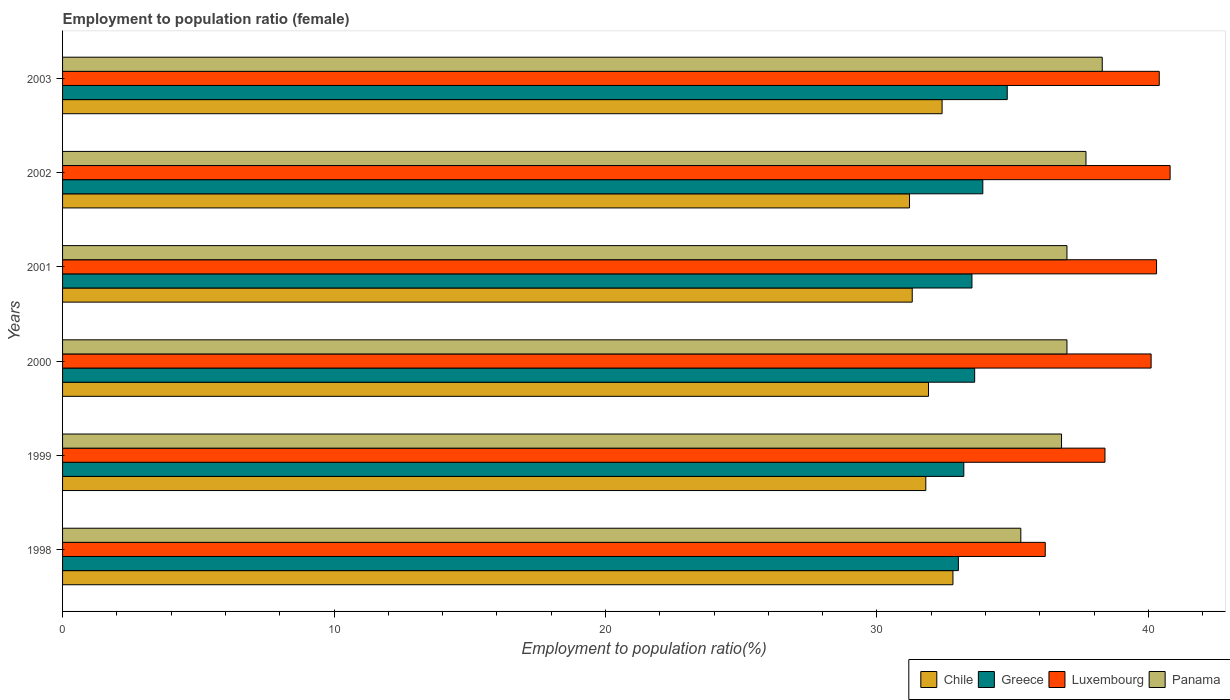How many groups of bars are there?
Provide a short and direct response. 6. Are the number of bars per tick equal to the number of legend labels?
Ensure brevity in your answer.  Yes. How many bars are there on the 2nd tick from the top?
Your answer should be compact. 4. How many bars are there on the 4th tick from the bottom?
Provide a short and direct response. 4. What is the label of the 6th group of bars from the top?
Offer a very short reply. 1998. In how many cases, is the number of bars for a given year not equal to the number of legend labels?
Ensure brevity in your answer.  0. What is the employment to population ratio in Chile in 1998?
Give a very brief answer. 32.8. Across all years, what is the maximum employment to population ratio in Luxembourg?
Your answer should be very brief. 40.8. Across all years, what is the minimum employment to population ratio in Greece?
Keep it short and to the point. 33. In which year was the employment to population ratio in Greece maximum?
Your response must be concise. 2003. In which year was the employment to population ratio in Greece minimum?
Ensure brevity in your answer.  1998. What is the total employment to population ratio in Luxembourg in the graph?
Offer a very short reply. 236.2. What is the difference between the employment to population ratio in Greece in 2000 and that in 2001?
Offer a very short reply. 0.1. What is the difference between the employment to population ratio in Chile in 1998 and the employment to population ratio in Luxembourg in 2002?
Give a very brief answer. -8. What is the average employment to population ratio in Greece per year?
Offer a terse response. 33.67. In the year 2002, what is the difference between the employment to population ratio in Panama and employment to population ratio in Greece?
Ensure brevity in your answer.  3.8. What is the ratio of the employment to population ratio in Chile in 1998 to that in 2001?
Offer a very short reply. 1.05. Is the employment to population ratio in Greece in 1999 less than that in 2002?
Your response must be concise. Yes. What is the difference between the highest and the second highest employment to population ratio in Greece?
Your response must be concise. 0.9. What is the difference between the highest and the lowest employment to population ratio in Greece?
Ensure brevity in your answer.  1.8. In how many years, is the employment to population ratio in Chile greater than the average employment to population ratio in Chile taken over all years?
Provide a succinct answer. 2. Is the sum of the employment to population ratio in Panama in 1999 and 2000 greater than the maximum employment to population ratio in Luxembourg across all years?
Offer a terse response. Yes. Is it the case that in every year, the sum of the employment to population ratio in Greece and employment to population ratio in Chile is greater than the sum of employment to population ratio in Panama and employment to population ratio in Luxembourg?
Give a very brief answer. No. What does the 2nd bar from the top in 2003 represents?
Your answer should be compact. Luxembourg. What does the 3rd bar from the bottom in 2000 represents?
Your answer should be compact. Luxembourg. What is the difference between two consecutive major ticks on the X-axis?
Your answer should be very brief. 10. Does the graph contain any zero values?
Your answer should be compact. No. Where does the legend appear in the graph?
Provide a succinct answer. Bottom right. What is the title of the graph?
Keep it short and to the point. Employment to population ratio (female). What is the Employment to population ratio(%) of Chile in 1998?
Your response must be concise. 32.8. What is the Employment to population ratio(%) of Luxembourg in 1998?
Offer a very short reply. 36.2. What is the Employment to population ratio(%) in Panama in 1998?
Offer a very short reply. 35.3. What is the Employment to population ratio(%) of Chile in 1999?
Ensure brevity in your answer.  31.8. What is the Employment to population ratio(%) of Greece in 1999?
Offer a very short reply. 33.2. What is the Employment to population ratio(%) of Luxembourg in 1999?
Give a very brief answer. 38.4. What is the Employment to population ratio(%) of Panama in 1999?
Your response must be concise. 36.8. What is the Employment to population ratio(%) of Chile in 2000?
Offer a very short reply. 31.9. What is the Employment to population ratio(%) in Greece in 2000?
Your response must be concise. 33.6. What is the Employment to population ratio(%) of Luxembourg in 2000?
Your response must be concise. 40.1. What is the Employment to population ratio(%) of Panama in 2000?
Provide a short and direct response. 37. What is the Employment to population ratio(%) of Chile in 2001?
Provide a short and direct response. 31.3. What is the Employment to population ratio(%) of Greece in 2001?
Ensure brevity in your answer.  33.5. What is the Employment to population ratio(%) in Luxembourg in 2001?
Make the answer very short. 40.3. What is the Employment to population ratio(%) in Panama in 2001?
Provide a short and direct response. 37. What is the Employment to population ratio(%) of Chile in 2002?
Your answer should be compact. 31.2. What is the Employment to population ratio(%) in Greece in 2002?
Keep it short and to the point. 33.9. What is the Employment to population ratio(%) in Luxembourg in 2002?
Provide a succinct answer. 40.8. What is the Employment to population ratio(%) of Panama in 2002?
Provide a short and direct response. 37.7. What is the Employment to population ratio(%) of Chile in 2003?
Offer a very short reply. 32.4. What is the Employment to population ratio(%) in Greece in 2003?
Offer a terse response. 34.8. What is the Employment to population ratio(%) in Luxembourg in 2003?
Give a very brief answer. 40.4. What is the Employment to population ratio(%) in Panama in 2003?
Your answer should be very brief. 38.3. Across all years, what is the maximum Employment to population ratio(%) in Chile?
Keep it short and to the point. 32.8. Across all years, what is the maximum Employment to population ratio(%) in Greece?
Offer a very short reply. 34.8. Across all years, what is the maximum Employment to population ratio(%) of Luxembourg?
Offer a terse response. 40.8. Across all years, what is the maximum Employment to population ratio(%) of Panama?
Provide a succinct answer. 38.3. Across all years, what is the minimum Employment to population ratio(%) of Chile?
Offer a very short reply. 31.2. Across all years, what is the minimum Employment to population ratio(%) in Greece?
Your answer should be very brief. 33. Across all years, what is the minimum Employment to population ratio(%) of Luxembourg?
Offer a terse response. 36.2. Across all years, what is the minimum Employment to population ratio(%) of Panama?
Keep it short and to the point. 35.3. What is the total Employment to population ratio(%) of Chile in the graph?
Offer a very short reply. 191.4. What is the total Employment to population ratio(%) of Greece in the graph?
Make the answer very short. 202. What is the total Employment to population ratio(%) of Luxembourg in the graph?
Ensure brevity in your answer.  236.2. What is the total Employment to population ratio(%) in Panama in the graph?
Offer a very short reply. 222.1. What is the difference between the Employment to population ratio(%) of Panama in 1998 and that in 1999?
Your answer should be compact. -1.5. What is the difference between the Employment to population ratio(%) of Greece in 1998 and that in 2000?
Ensure brevity in your answer.  -0.6. What is the difference between the Employment to population ratio(%) in Luxembourg in 1998 and that in 2000?
Your response must be concise. -3.9. What is the difference between the Employment to population ratio(%) of Luxembourg in 1998 and that in 2001?
Offer a very short reply. -4.1. What is the difference between the Employment to population ratio(%) in Chile in 1998 and that in 2002?
Your answer should be very brief. 1.6. What is the difference between the Employment to population ratio(%) of Greece in 1998 and that in 2002?
Provide a short and direct response. -0.9. What is the difference between the Employment to population ratio(%) in Luxembourg in 1998 and that in 2002?
Make the answer very short. -4.6. What is the difference between the Employment to population ratio(%) in Chile in 1998 and that in 2003?
Your response must be concise. 0.4. What is the difference between the Employment to population ratio(%) of Greece in 1998 and that in 2003?
Keep it short and to the point. -1.8. What is the difference between the Employment to population ratio(%) in Luxembourg in 1998 and that in 2003?
Ensure brevity in your answer.  -4.2. What is the difference between the Employment to population ratio(%) in Chile in 1999 and that in 2000?
Your response must be concise. -0.1. What is the difference between the Employment to population ratio(%) of Luxembourg in 1999 and that in 2000?
Give a very brief answer. -1.7. What is the difference between the Employment to population ratio(%) in Panama in 1999 and that in 2000?
Keep it short and to the point. -0.2. What is the difference between the Employment to population ratio(%) of Chile in 1999 and that in 2001?
Provide a succinct answer. 0.5. What is the difference between the Employment to population ratio(%) in Greece in 1999 and that in 2001?
Keep it short and to the point. -0.3. What is the difference between the Employment to population ratio(%) of Chile in 1999 and that in 2002?
Offer a terse response. 0.6. What is the difference between the Employment to population ratio(%) of Chile in 1999 and that in 2003?
Offer a very short reply. -0.6. What is the difference between the Employment to population ratio(%) in Luxembourg in 1999 and that in 2003?
Keep it short and to the point. -2. What is the difference between the Employment to population ratio(%) in Greece in 2000 and that in 2001?
Your response must be concise. 0.1. What is the difference between the Employment to population ratio(%) in Greece in 2000 and that in 2002?
Ensure brevity in your answer.  -0.3. What is the difference between the Employment to population ratio(%) in Luxembourg in 2000 and that in 2002?
Offer a terse response. -0.7. What is the difference between the Employment to population ratio(%) of Chile in 2000 and that in 2003?
Your answer should be compact. -0.5. What is the difference between the Employment to population ratio(%) of Greece in 2000 and that in 2003?
Your response must be concise. -1.2. What is the difference between the Employment to population ratio(%) in Luxembourg in 2000 and that in 2003?
Keep it short and to the point. -0.3. What is the difference between the Employment to population ratio(%) in Greece in 2001 and that in 2002?
Provide a succinct answer. -0.4. What is the difference between the Employment to population ratio(%) in Greece in 2001 and that in 2003?
Make the answer very short. -1.3. What is the difference between the Employment to population ratio(%) in Luxembourg in 2001 and that in 2003?
Make the answer very short. -0.1. What is the difference between the Employment to population ratio(%) in Chile in 2002 and that in 2003?
Your answer should be very brief. -1.2. What is the difference between the Employment to population ratio(%) of Chile in 1998 and the Employment to population ratio(%) of Greece in 1999?
Provide a short and direct response. -0.4. What is the difference between the Employment to population ratio(%) of Greece in 1998 and the Employment to population ratio(%) of Panama in 1999?
Ensure brevity in your answer.  -3.8. What is the difference between the Employment to population ratio(%) of Luxembourg in 1998 and the Employment to population ratio(%) of Panama in 1999?
Your answer should be compact. -0.6. What is the difference between the Employment to population ratio(%) in Chile in 1998 and the Employment to population ratio(%) in Greece in 2000?
Keep it short and to the point. -0.8. What is the difference between the Employment to population ratio(%) in Chile in 1998 and the Employment to population ratio(%) in Luxembourg in 2000?
Give a very brief answer. -7.3. What is the difference between the Employment to population ratio(%) of Greece in 1998 and the Employment to population ratio(%) of Panama in 2000?
Keep it short and to the point. -4. What is the difference between the Employment to population ratio(%) of Chile in 1998 and the Employment to population ratio(%) of Greece in 2001?
Your answer should be compact. -0.7. What is the difference between the Employment to population ratio(%) of Greece in 1998 and the Employment to population ratio(%) of Luxembourg in 2001?
Offer a very short reply. -7.3. What is the difference between the Employment to population ratio(%) in Chile in 1998 and the Employment to population ratio(%) in Greece in 2002?
Offer a terse response. -1.1. What is the difference between the Employment to population ratio(%) of Chile in 1998 and the Employment to population ratio(%) of Panama in 2002?
Offer a very short reply. -4.9. What is the difference between the Employment to population ratio(%) in Luxembourg in 1998 and the Employment to population ratio(%) in Panama in 2002?
Provide a short and direct response. -1.5. What is the difference between the Employment to population ratio(%) in Greece in 1998 and the Employment to population ratio(%) in Panama in 2003?
Give a very brief answer. -5.3. What is the difference between the Employment to population ratio(%) of Luxembourg in 1998 and the Employment to population ratio(%) of Panama in 2003?
Ensure brevity in your answer.  -2.1. What is the difference between the Employment to population ratio(%) in Chile in 1999 and the Employment to population ratio(%) in Panama in 2000?
Offer a terse response. -5.2. What is the difference between the Employment to population ratio(%) in Chile in 1999 and the Employment to population ratio(%) in Greece in 2001?
Offer a terse response. -1.7. What is the difference between the Employment to population ratio(%) in Chile in 1999 and the Employment to population ratio(%) in Luxembourg in 2001?
Make the answer very short. -8.5. What is the difference between the Employment to population ratio(%) in Greece in 1999 and the Employment to population ratio(%) in Luxembourg in 2001?
Ensure brevity in your answer.  -7.1. What is the difference between the Employment to population ratio(%) in Greece in 1999 and the Employment to population ratio(%) in Panama in 2001?
Ensure brevity in your answer.  -3.8. What is the difference between the Employment to population ratio(%) of Chile in 1999 and the Employment to population ratio(%) of Luxembourg in 2002?
Offer a very short reply. -9. What is the difference between the Employment to population ratio(%) in Greece in 1999 and the Employment to population ratio(%) in Luxembourg in 2002?
Provide a short and direct response. -7.6. What is the difference between the Employment to population ratio(%) of Greece in 1999 and the Employment to population ratio(%) of Panama in 2002?
Offer a terse response. -4.5. What is the difference between the Employment to population ratio(%) in Luxembourg in 1999 and the Employment to population ratio(%) in Panama in 2002?
Offer a terse response. 0.7. What is the difference between the Employment to population ratio(%) of Chile in 1999 and the Employment to population ratio(%) of Greece in 2003?
Offer a terse response. -3. What is the difference between the Employment to population ratio(%) in Chile in 1999 and the Employment to population ratio(%) in Panama in 2003?
Provide a succinct answer. -6.5. What is the difference between the Employment to population ratio(%) of Greece in 1999 and the Employment to population ratio(%) of Panama in 2003?
Offer a terse response. -5.1. What is the difference between the Employment to population ratio(%) in Luxembourg in 1999 and the Employment to population ratio(%) in Panama in 2003?
Your answer should be compact. 0.1. What is the difference between the Employment to population ratio(%) in Greece in 2000 and the Employment to population ratio(%) in Panama in 2001?
Provide a short and direct response. -3.4. What is the difference between the Employment to population ratio(%) of Chile in 2000 and the Employment to population ratio(%) of Greece in 2002?
Keep it short and to the point. -2. What is the difference between the Employment to population ratio(%) in Chile in 2000 and the Employment to population ratio(%) in Luxembourg in 2002?
Keep it short and to the point. -8.9. What is the difference between the Employment to population ratio(%) of Chile in 2000 and the Employment to population ratio(%) of Panama in 2002?
Your answer should be compact. -5.8. What is the difference between the Employment to population ratio(%) of Greece in 2000 and the Employment to population ratio(%) of Luxembourg in 2002?
Ensure brevity in your answer.  -7.2. What is the difference between the Employment to population ratio(%) of Luxembourg in 2000 and the Employment to population ratio(%) of Panama in 2002?
Your answer should be very brief. 2.4. What is the difference between the Employment to population ratio(%) of Chile in 2000 and the Employment to population ratio(%) of Greece in 2003?
Your answer should be very brief. -2.9. What is the difference between the Employment to population ratio(%) of Chile in 2000 and the Employment to population ratio(%) of Luxembourg in 2003?
Give a very brief answer. -8.5. What is the difference between the Employment to population ratio(%) of Chile in 2001 and the Employment to population ratio(%) of Luxembourg in 2002?
Ensure brevity in your answer.  -9.5. What is the difference between the Employment to population ratio(%) of Chile in 2001 and the Employment to population ratio(%) of Panama in 2002?
Provide a succinct answer. -6.4. What is the difference between the Employment to population ratio(%) of Greece in 2001 and the Employment to population ratio(%) of Luxembourg in 2002?
Ensure brevity in your answer.  -7.3. What is the difference between the Employment to population ratio(%) in Greece in 2001 and the Employment to population ratio(%) in Panama in 2002?
Make the answer very short. -4.2. What is the difference between the Employment to population ratio(%) in Luxembourg in 2001 and the Employment to population ratio(%) in Panama in 2002?
Ensure brevity in your answer.  2.6. What is the difference between the Employment to population ratio(%) in Greece in 2001 and the Employment to population ratio(%) in Luxembourg in 2003?
Provide a succinct answer. -6.9. What is the difference between the Employment to population ratio(%) of Greece in 2001 and the Employment to population ratio(%) of Panama in 2003?
Ensure brevity in your answer.  -4.8. What is the difference between the Employment to population ratio(%) in Chile in 2002 and the Employment to population ratio(%) in Greece in 2003?
Offer a very short reply. -3.6. What is the difference between the Employment to population ratio(%) in Chile in 2002 and the Employment to population ratio(%) in Luxembourg in 2003?
Your response must be concise. -9.2. What is the difference between the Employment to population ratio(%) of Greece in 2002 and the Employment to population ratio(%) of Luxembourg in 2003?
Your answer should be compact. -6.5. What is the average Employment to population ratio(%) of Chile per year?
Provide a succinct answer. 31.9. What is the average Employment to population ratio(%) of Greece per year?
Ensure brevity in your answer.  33.67. What is the average Employment to population ratio(%) in Luxembourg per year?
Offer a very short reply. 39.37. What is the average Employment to population ratio(%) in Panama per year?
Make the answer very short. 37.02. In the year 1998, what is the difference between the Employment to population ratio(%) in Chile and Employment to population ratio(%) in Luxembourg?
Ensure brevity in your answer.  -3.4. In the year 1998, what is the difference between the Employment to population ratio(%) in Chile and Employment to population ratio(%) in Panama?
Provide a short and direct response. -2.5. In the year 1998, what is the difference between the Employment to population ratio(%) of Greece and Employment to population ratio(%) of Luxembourg?
Keep it short and to the point. -3.2. In the year 1998, what is the difference between the Employment to population ratio(%) in Luxembourg and Employment to population ratio(%) in Panama?
Make the answer very short. 0.9. In the year 1999, what is the difference between the Employment to population ratio(%) of Chile and Employment to population ratio(%) of Luxembourg?
Your answer should be compact. -6.6. In the year 1999, what is the difference between the Employment to population ratio(%) of Chile and Employment to population ratio(%) of Panama?
Give a very brief answer. -5. In the year 1999, what is the difference between the Employment to population ratio(%) of Greece and Employment to population ratio(%) of Luxembourg?
Your answer should be very brief. -5.2. In the year 1999, what is the difference between the Employment to population ratio(%) of Greece and Employment to population ratio(%) of Panama?
Make the answer very short. -3.6. In the year 2000, what is the difference between the Employment to population ratio(%) in Chile and Employment to population ratio(%) in Panama?
Your answer should be very brief. -5.1. In the year 2001, what is the difference between the Employment to population ratio(%) in Chile and Employment to population ratio(%) in Greece?
Make the answer very short. -2.2. In the year 2001, what is the difference between the Employment to population ratio(%) in Chile and Employment to population ratio(%) in Luxembourg?
Make the answer very short. -9. In the year 2001, what is the difference between the Employment to population ratio(%) of Greece and Employment to population ratio(%) of Panama?
Provide a short and direct response. -3.5. In the year 2001, what is the difference between the Employment to population ratio(%) in Luxembourg and Employment to population ratio(%) in Panama?
Make the answer very short. 3.3. In the year 2002, what is the difference between the Employment to population ratio(%) in Chile and Employment to population ratio(%) in Luxembourg?
Your response must be concise. -9.6. In the year 2002, what is the difference between the Employment to population ratio(%) in Greece and Employment to population ratio(%) in Luxembourg?
Offer a very short reply. -6.9. In the year 2003, what is the difference between the Employment to population ratio(%) of Chile and Employment to population ratio(%) of Greece?
Make the answer very short. -2.4. In the year 2003, what is the difference between the Employment to population ratio(%) in Chile and Employment to population ratio(%) in Luxembourg?
Provide a short and direct response. -8. In the year 2003, what is the difference between the Employment to population ratio(%) in Greece and Employment to population ratio(%) in Panama?
Offer a very short reply. -3.5. In the year 2003, what is the difference between the Employment to population ratio(%) in Luxembourg and Employment to population ratio(%) in Panama?
Your answer should be very brief. 2.1. What is the ratio of the Employment to population ratio(%) in Chile in 1998 to that in 1999?
Your answer should be very brief. 1.03. What is the ratio of the Employment to population ratio(%) of Luxembourg in 1998 to that in 1999?
Keep it short and to the point. 0.94. What is the ratio of the Employment to population ratio(%) in Panama in 1998 to that in 1999?
Your answer should be very brief. 0.96. What is the ratio of the Employment to population ratio(%) in Chile in 1998 to that in 2000?
Provide a succinct answer. 1.03. What is the ratio of the Employment to population ratio(%) in Greece in 1998 to that in 2000?
Offer a very short reply. 0.98. What is the ratio of the Employment to population ratio(%) of Luxembourg in 1998 to that in 2000?
Keep it short and to the point. 0.9. What is the ratio of the Employment to population ratio(%) in Panama in 1998 to that in 2000?
Your answer should be very brief. 0.95. What is the ratio of the Employment to population ratio(%) of Chile in 1998 to that in 2001?
Give a very brief answer. 1.05. What is the ratio of the Employment to population ratio(%) in Greece in 1998 to that in 2001?
Offer a terse response. 0.99. What is the ratio of the Employment to population ratio(%) in Luxembourg in 1998 to that in 2001?
Offer a terse response. 0.9. What is the ratio of the Employment to population ratio(%) in Panama in 1998 to that in 2001?
Offer a very short reply. 0.95. What is the ratio of the Employment to population ratio(%) in Chile in 1998 to that in 2002?
Your answer should be very brief. 1.05. What is the ratio of the Employment to population ratio(%) of Greece in 1998 to that in 2002?
Keep it short and to the point. 0.97. What is the ratio of the Employment to population ratio(%) in Luxembourg in 1998 to that in 2002?
Make the answer very short. 0.89. What is the ratio of the Employment to population ratio(%) in Panama in 1998 to that in 2002?
Offer a terse response. 0.94. What is the ratio of the Employment to population ratio(%) of Chile in 1998 to that in 2003?
Offer a terse response. 1.01. What is the ratio of the Employment to population ratio(%) in Greece in 1998 to that in 2003?
Keep it short and to the point. 0.95. What is the ratio of the Employment to population ratio(%) in Luxembourg in 1998 to that in 2003?
Offer a terse response. 0.9. What is the ratio of the Employment to population ratio(%) in Panama in 1998 to that in 2003?
Offer a terse response. 0.92. What is the ratio of the Employment to population ratio(%) of Chile in 1999 to that in 2000?
Keep it short and to the point. 1. What is the ratio of the Employment to population ratio(%) of Greece in 1999 to that in 2000?
Make the answer very short. 0.99. What is the ratio of the Employment to population ratio(%) in Luxembourg in 1999 to that in 2000?
Make the answer very short. 0.96. What is the ratio of the Employment to population ratio(%) in Greece in 1999 to that in 2001?
Ensure brevity in your answer.  0.99. What is the ratio of the Employment to population ratio(%) in Luxembourg in 1999 to that in 2001?
Ensure brevity in your answer.  0.95. What is the ratio of the Employment to population ratio(%) of Panama in 1999 to that in 2001?
Provide a short and direct response. 0.99. What is the ratio of the Employment to population ratio(%) of Chile in 1999 to that in 2002?
Provide a short and direct response. 1.02. What is the ratio of the Employment to population ratio(%) of Greece in 1999 to that in 2002?
Your answer should be compact. 0.98. What is the ratio of the Employment to population ratio(%) of Panama in 1999 to that in 2002?
Provide a succinct answer. 0.98. What is the ratio of the Employment to population ratio(%) in Chile in 1999 to that in 2003?
Your answer should be very brief. 0.98. What is the ratio of the Employment to population ratio(%) in Greece in 1999 to that in 2003?
Offer a terse response. 0.95. What is the ratio of the Employment to population ratio(%) of Luxembourg in 1999 to that in 2003?
Provide a short and direct response. 0.95. What is the ratio of the Employment to population ratio(%) in Panama in 1999 to that in 2003?
Give a very brief answer. 0.96. What is the ratio of the Employment to population ratio(%) of Chile in 2000 to that in 2001?
Provide a succinct answer. 1.02. What is the ratio of the Employment to population ratio(%) in Greece in 2000 to that in 2001?
Offer a very short reply. 1. What is the ratio of the Employment to population ratio(%) in Luxembourg in 2000 to that in 2001?
Ensure brevity in your answer.  0.99. What is the ratio of the Employment to population ratio(%) of Panama in 2000 to that in 2001?
Provide a succinct answer. 1. What is the ratio of the Employment to population ratio(%) in Chile in 2000 to that in 2002?
Keep it short and to the point. 1.02. What is the ratio of the Employment to population ratio(%) of Luxembourg in 2000 to that in 2002?
Give a very brief answer. 0.98. What is the ratio of the Employment to population ratio(%) in Panama in 2000 to that in 2002?
Offer a very short reply. 0.98. What is the ratio of the Employment to population ratio(%) of Chile in 2000 to that in 2003?
Provide a succinct answer. 0.98. What is the ratio of the Employment to population ratio(%) of Greece in 2000 to that in 2003?
Give a very brief answer. 0.97. What is the ratio of the Employment to population ratio(%) in Panama in 2000 to that in 2003?
Ensure brevity in your answer.  0.97. What is the ratio of the Employment to population ratio(%) in Chile in 2001 to that in 2002?
Provide a short and direct response. 1. What is the ratio of the Employment to population ratio(%) in Panama in 2001 to that in 2002?
Offer a terse response. 0.98. What is the ratio of the Employment to population ratio(%) of Greece in 2001 to that in 2003?
Keep it short and to the point. 0.96. What is the ratio of the Employment to population ratio(%) of Panama in 2001 to that in 2003?
Your answer should be very brief. 0.97. What is the ratio of the Employment to population ratio(%) in Greece in 2002 to that in 2003?
Your answer should be compact. 0.97. What is the ratio of the Employment to population ratio(%) in Luxembourg in 2002 to that in 2003?
Ensure brevity in your answer.  1.01. What is the ratio of the Employment to population ratio(%) of Panama in 2002 to that in 2003?
Offer a terse response. 0.98. What is the difference between the highest and the second highest Employment to population ratio(%) of Luxembourg?
Provide a succinct answer. 0.4. What is the difference between the highest and the lowest Employment to population ratio(%) of Greece?
Offer a very short reply. 1.8. What is the difference between the highest and the lowest Employment to population ratio(%) of Panama?
Offer a very short reply. 3. 